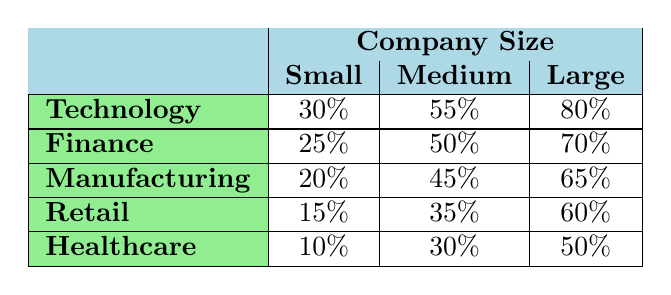What is the participation percentage of Small companies in the Technology industry? From the table, you can see the participation percentage for small companies in the Technology industry is listed directly as 30%.
Answer: 30% What is the participation percentage of Large companies in the Manufacturing industry? The table shows the participation percentage for Large companies in the Manufacturing industry as 65%.
Answer: 65% Which industry has the highest participation rate for Medium companies? By comparing the participation rates for Medium companies across all industries, Technology has the highest rate at 55%.
Answer: Technology Is the participation rate of Small companies in Retail higher than in Healthcare? The participation rate for Small companies in Retail is 15%, while in Healthcare it is 10%. Since 15% is greater than 10%, the statement is true.
Answer: Yes What is the average participation rate of Medium companies across all industries? To find the average, add the Medium participation rates: (55 + 50 + 45 + 35 + 30) = 215. There are 5 industries, so the average is 215/5 = 43%.
Answer: 43% Which industry has the lowest participation rate for Small companies? By reviewing the table, Healthcare has the lowest participation rate for Small companies at 10%.
Answer: Healthcare What is the difference in participation rates between Large and Small companies in the Finance sector? The participation rate for Large companies in Finance is 70% and for Small companies, it is 25%. Subtracting these gives 70 - 25 = 45%.
Answer: 45% Is there a relation between company size and participation rate in the Manufacturing industry? The data shows an increase in participation rates from Small (20%) to Medium (45%) to Large (65%) companies, indicating a positive correlation between size and participation rate.
Answer: Yes What is the total participation rate for all company sizes in the Technology industry combined? Add the participation rates for all sizes in Technology: 30% + 55% + 80% = 165%.
Answer: 165% 